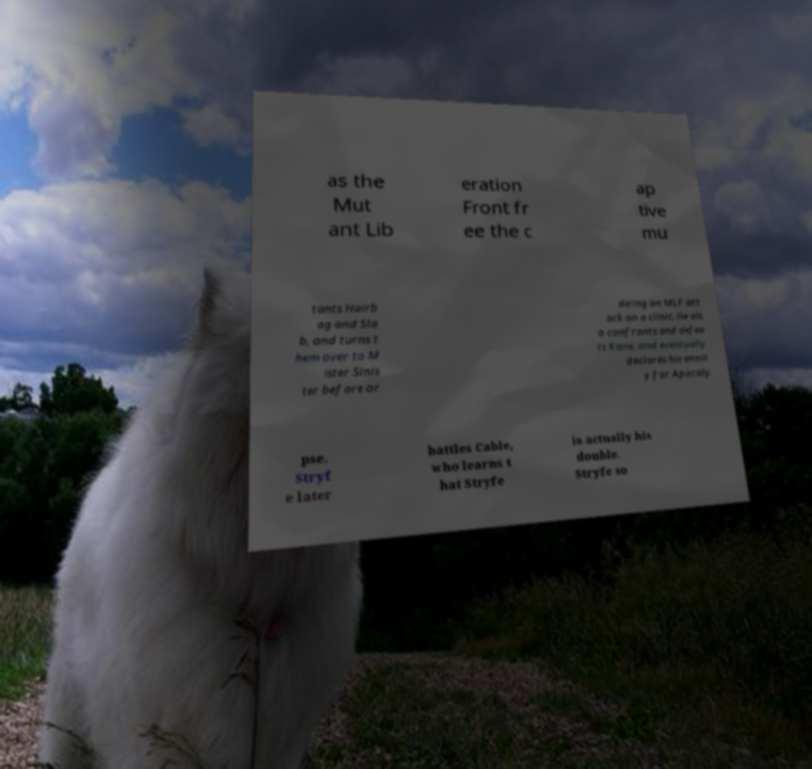Can you read and provide the text displayed in the image?This photo seems to have some interesting text. Can you extract and type it out for me? as the Mut ant Lib eration Front fr ee the c ap tive mu tants Hairb ag and Sla b, and turns t hem over to M ister Sinis ter before or dering an MLF att ack on a clinic. He als o confronts and defea ts Kane, and eventually declares his enmit y for Apocaly pse. Stryf e later battles Cable, who learns t hat Stryfe is actually his double. Stryfe so 